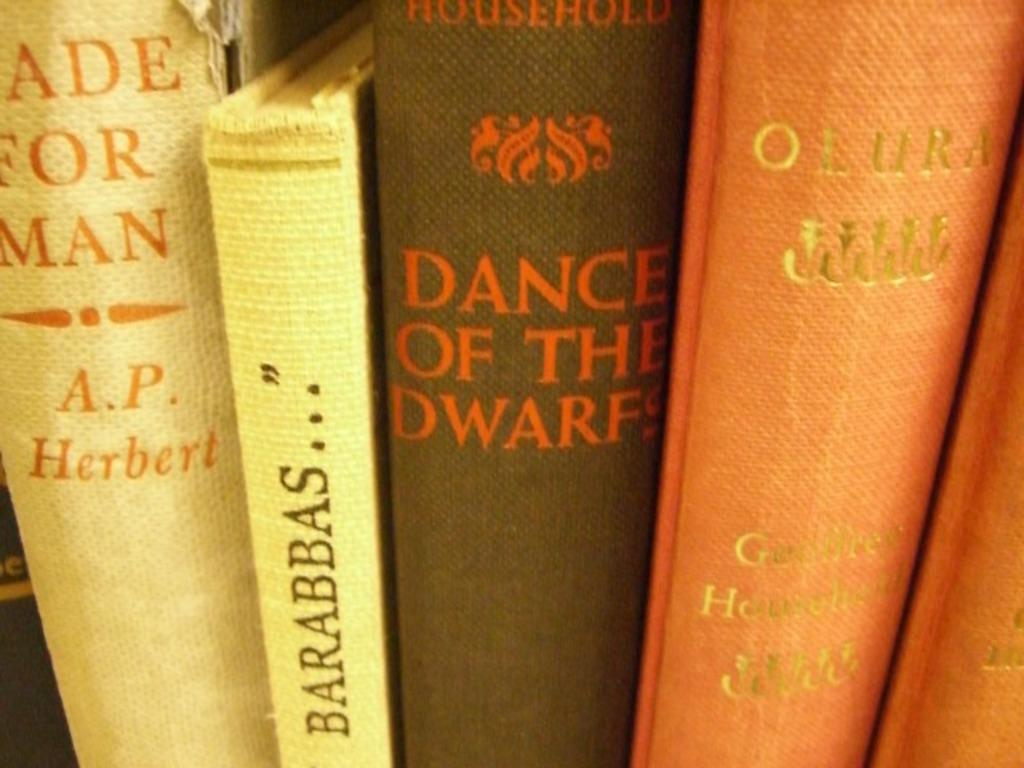<image>
Present a compact description of the photo's key features. A book by A.P. Herbert is next to other books. 